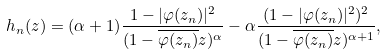<formula> <loc_0><loc_0><loc_500><loc_500>h _ { n } ( z ) = ( \alpha + 1 ) \frac { 1 - | \varphi ( z _ { n } ) | ^ { 2 } } { ( 1 - \overline { \varphi ( z _ { n } ) } z ) ^ { \alpha } } - \alpha \frac { ( 1 - | \varphi ( z _ { n } ) | ^ { 2 } ) ^ { 2 } } { ( 1 - \overline { \varphi ( z _ { n } ) } z ) ^ { \alpha + 1 } } ,</formula> 